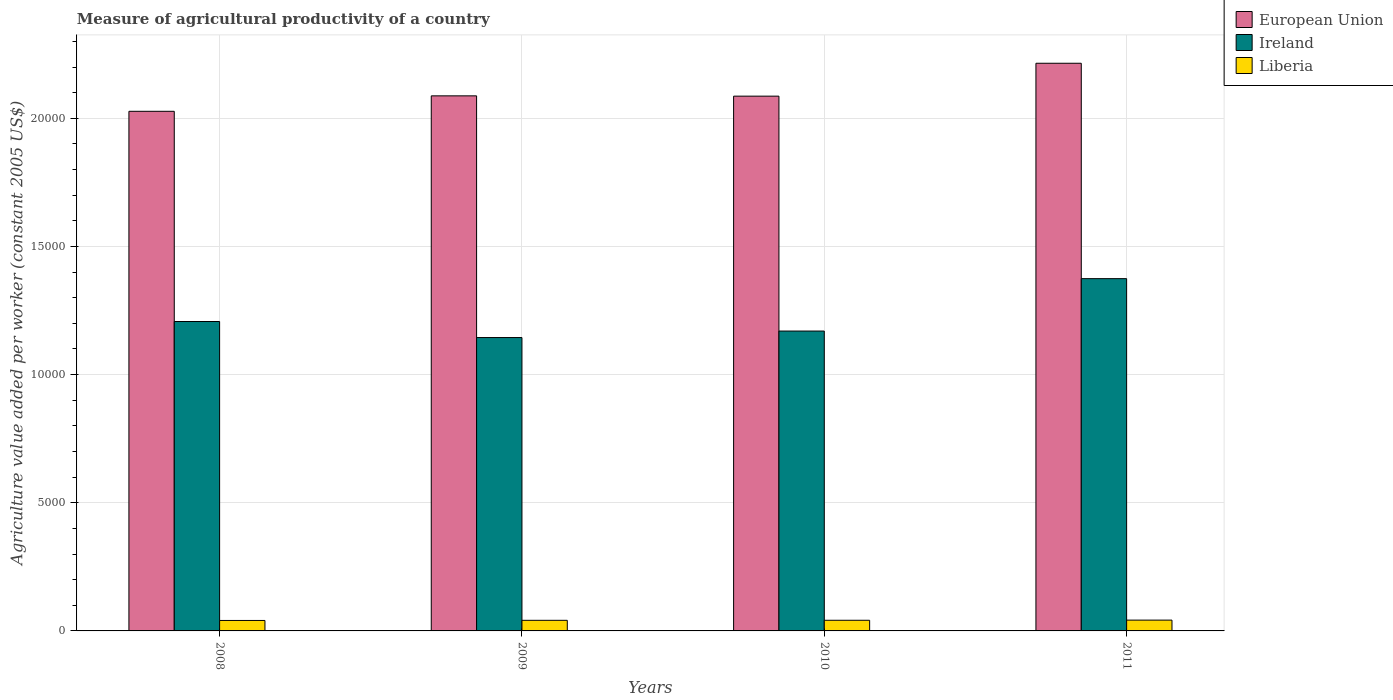Are the number of bars per tick equal to the number of legend labels?
Keep it short and to the point. Yes. Are the number of bars on each tick of the X-axis equal?
Your answer should be compact. Yes. How many bars are there on the 2nd tick from the right?
Make the answer very short. 3. What is the measure of agricultural productivity in European Union in 2009?
Ensure brevity in your answer.  2.09e+04. Across all years, what is the maximum measure of agricultural productivity in Ireland?
Provide a short and direct response. 1.37e+04. Across all years, what is the minimum measure of agricultural productivity in Ireland?
Your answer should be compact. 1.14e+04. What is the total measure of agricultural productivity in European Union in the graph?
Your answer should be compact. 8.42e+04. What is the difference between the measure of agricultural productivity in European Union in 2009 and that in 2010?
Make the answer very short. 11.47. What is the difference between the measure of agricultural productivity in European Union in 2011 and the measure of agricultural productivity in Ireland in 2010?
Your answer should be compact. 1.04e+04. What is the average measure of agricultural productivity in Liberia per year?
Ensure brevity in your answer.  414.7. In the year 2008, what is the difference between the measure of agricultural productivity in European Union and measure of agricultural productivity in Ireland?
Your answer should be very brief. 8201.47. What is the ratio of the measure of agricultural productivity in European Union in 2008 to that in 2009?
Provide a succinct answer. 0.97. Is the measure of agricultural productivity in Ireland in 2009 less than that in 2010?
Your answer should be very brief. Yes. Is the difference between the measure of agricultural productivity in European Union in 2008 and 2010 greater than the difference between the measure of agricultural productivity in Ireland in 2008 and 2010?
Provide a succinct answer. No. What is the difference between the highest and the second highest measure of agricultural productivity in European Union?
Your answer should be very brief. 1271.79. What is the difference between the highest and the lowest measure of agricultural productivity in Liberia?
Make the answer very short. 13.71. Is the sum of the measure of agricultural productivity in Liberia in 2008 and 2009 greater than the maximum measure of agricultural productivity in Ireland across all years?
Your response must be concise. No. What does the 1st bar from the right in 2008 represents?
Ensure brevity in your answer.  Liberia. Is it the case that in every year, the sum of the measure of agricultural productivity in Ireland and measure of agricultural productivity in European Union is greater than the measure of agricultural productivity in Liberia?
Your answer should be compact. Yes. How many bars are there?
Your answer should be very brief. 12. Are all the bars in the graph horizontal?
Provide a succinct answer. No. How many years are there in the graph?
Your answer should be compact. 4. What is the difference between two consecutive major ticks on the Y-axis?
Your answer should be very brief. 5000. Where does the legend appear in the graph?
Your answer should be compact. Top right. How many legend labels are there?
Ensure brevity in your answer.  3. How are the legend labels stacked?
Your response must be concise. Vertical. What is the title of the graph?
Offer a terse response. Measure of agricultural productivity of a country. Does "Senegal" appear as one of the legend labels in the graph?
Provide a short and direct response. No. What is the label or title of the X-axis?
Offer a terse response. Years. What is the label or title of the Y-axis?
Offer a very short reply. Agriculture value added per worker (constant 2005 US$). What is the Agriculture value added per worker (constant 2005 US$) in European Union in 2008?
Offer a terse response. 2.03e+04. What is the Agriculture value added per worker (constant 2005 US$) in Ireland in 2008?
Your answer should be compact. 1.21e+04. What is the Agriculture value added per worker (constant 2005 US$) in Liberia in 2008?
Offer a very short reply. 407.86. What is the Agriculture value added per worker (constant 2005 US$) in European Union in 2009?
Your response must be concise. 2.09e+04. What is the Agriculture value added per worker (constant 2005 US$) of Ireland in 2009?
Your response must be concise. 1.14e+04. What is the Agriculture value added per worker (constant 2005 US$) in Liberia in 2009?
Ensure brevity in your answer.  413.81. What is the Agriculture value added per worker (constant 2005 US$) in European Union in 2010?
Keep it short and to the point. 2.09e+04. What is the Agriculture value added per worker (constant 2005 US$) of Ireland in 2010?
Offer a very short reply. 1.17e+04. What is the Agriculture value added per worker (constant 2005 US$) of Liberia in 2010?
Make the answer very short. 415.57. What is the Agriculture value added per worker (constant 2005 US$) in European Union in 2011?
Keep it short and to the point. 2.21e+04. What is the Agriculture value added per worker (constant 2005 US$) of Ireland in 2011?
Keep it short and to the point. 1.37e+04. What is the Agriculture value added per worker (constant 2005 US$) of Liberia in 2011?
Provide a short and direct response. 421.57. Across all years, what is the maximum Agriculture value added per worker (constant 2005 US$) in European Union?
Ensure brevity in your answer.  2.21e+04. Across all years, what is the maximum Agriculture value added per worker (constant 2005 US$) of Ireland?
Keep it short and to the point. 1.37e+04. Across all years, what is the maximum Agriculture value added per worker (constant 2005 US$) of Liberia?
Provide a short and direct response. 421.57. Across all years, what is the minimum Agriculture value added per worker (constant 2005 US$) in European Union?
Keep it short and to the point. 2.03e+04. Across all years, what is the minimum Agriculture value added per worker (constant 2005 US$) in Ireland?
Your answer should be very brief. 1.14e+04. Across all years, what is the minimum Agriculture value added per worker (constant 2005 US$) of Liberia?
Offer a terse response. 407.86. What is the total Agriculture value added per worker (constant 2005 US$) of European Union in the graph?
Provide a succinct answer. 8.42e+04. What is the total Agriculture value added per worker (constant 2005 US$) in Ireland in the graph?
Give a very brief answer. 4.90e+04. What is the total Agriculture value added per worker (constant 2005 US$) in Liberia in the graph?
Provide a succinct answer. 1658.81. What is the difference between the Agriculture value added per worker (constant 2005 US$) in European Union in 2008 and that in 2009?
Ensure brevity in your answer.  -602.44. What is the difference between the Agriculture value added per worker (constant 2005 US$) of Ireland in 2008 and that in 2009?
Give a very brief answer. 625.84. What is the difference between the Agriculture value added per worker (constant 2005 US$) in Liberia in 2008 and that in 2009?
Give a very brief answer. -5.96. What is the difference between the Agriculture value added per worker (constant 2005 US$) in European Union in 2008 and that in 2010?
Offer a terse response. -590.97. What is the difference between the Agriculture value added per worker (constant 2005 US$) of Ireland in 2008 and that in 2010?
Offer a very short reply. 372.45. What is the difference between the Agriculture value added per worker (constant 2005 US$) of Liberia in 2008 and that in 2010?
Make the answer very short. -7.72. What is the difference between the Agriculture value added per worker (constant 2005 US$) in European Union in 2008 and that in 2011?
Provide a short and direct response. -1874.23. What is the difference between the Agriculture value added per worker (constant 2005 US$) in Ireland in 2008 and that in 2011?
Ensure brevity in your answer.  -1672.35. What is the difference between the Agriculture value added per worker (constant 2005 US$) in Liberia in 2008 and that in 2011?
Offer a very short reply. -13.71. What is the difference between the Agriculture value added per worker (constant 2005 US$) of European Union in 2009 and that in 2010?
Offer a very short reply. 11.47. What is the difference between the Agriculture value added per worker (constant 2005 US$) in Ireland in 2009 and that in 2010?
Your answer should be very brief. -253.39. What is the difference between the Agriculture value added per worker (constant 2005 US$) in Liberia in 2009 and that in 2010?
Offer a terse response. -1.76. What is the difference between the Agriculture value added per worker (constant 2005 US$) in European Union in 2009 and that in 2011?
Make the answer very short. -1271.79. What is the difference between the Agriculture value added per worker (constant 2005 US$) of Ireland in 2009 and that in 2011?
Make the answer very short. -2298.19. What is the difference between the Agriculture value added per worker (constant 2005 US$) of Liberia in 2009 and that in 2011?
Offer a very short reply. -7.76. What is the difference between the Agriculture value added per worker (constant 2005 US$) in European Union in 2010 and that in 2011?
Make the answer very short. -1283.26. What is the difference between the Agriculture value added per worker (constant 2005 US$) of Ireland in 2010 and that in 2011?
Your response must be concise. -2044.81. What is the difference between the Agriculture value added per worker (constant 2005 US$) in Liberia in 2010 and that in 2011?
Make the answer very short. -6. What is the difference between the Agriculture value added per worker (constant 2005 US$) in European Union in 2008 and the Agriculture value added per worker (constant 2005 US$) in Ireland in 2009?
Offer a very short reply. 8827.31. What is the difference between the Agriculture value added per worker (constant 2005 US$) of European Union in 2008 and the Agriculture value added per worker (constant 2005 US$) of Liberia in 2009?
Make the answer very short. 1.99e+04. What is the difference between the Agriculture value added per worker (constant 2005 US$) in Ireland in 2008 and the Agriculture value added per worker (constant 2005 US$) in Liberia in 2009?
Offer a very short reply. 1.17e+04. What is the difference between the Agriculture value added per worker (constant 2005 US$) of European Union in 2008 and the Agriculture value added per worker (constant 2005 US$) of Ireland in 2010?
Your answer should be compact. 8573.92. What is the difference between the Agriculture value added per worker (constant 2005 US$) of European Union in 2008 and the Agriculture value added per worker (constant 2005 US$) of Liberia in 2010?
Provide a succinct answer. 1.99e+04. What is the difference between the Agriculture value added per worker (constant 2005 US$) in Ireland in 2008 and the Agriculture value added per worker (constant 2005 US$) in Liberia in 2010?
Provide a short and direct response. 1.17e+04. What is the difference between the Agriculture value added per worker (constant 2005 US$) of European Union in 2008 and the Agriculture value added per worker (constant 2005 US$) of Ireland in 2011?
Offer a very short reply. 6529.12. What is the difference between the Agriculture value added per worker (constant 2005 US$) in European Union in 2008 and the Agriculture value added per worker (constant 2005 US$) in Liberia in 2011?
Your response must be concise. 1.99e+04. What is the difference between the Agriculture value added per worker (constant 2005 US$) of Ireland in 2008 and the Agriculture value added per worker (constant 2005 US$) of Liberia in 2011?
Your response must be concise. 1.17e+04. What is the difference between the Agriculture value added per worker (constant 2005 US$) of European Union in 2009 and the Agriculture value added per worker (constant 2005 US$) of Ireland in 2010?
Your answer should be very brief. 9176.36. What is the difference between the Agriculture value added per worker (constant 2005 US$) of European Union in 2009 and the Agriculture value added per worker (constant 2005 US$) of Liberia in 2010?
Make the answer very short. 2.05e+04. What is the difference between the Agriculture value added per worker (constant 2005 US$) in Ireland in 2009 and the Agriculture value added per worker (constant 2005 US$) in Liberia in 2010?
Keep it short and to the point. 1.10e+04. What is the difference between the Agriculture value added per worker (constant 2005 US$) in European Union in 2009 and the Agriculture value added per worker (constant 2005 US$) in Ireland in 2011?
Your answer should be compact. 7131.55. What is the difference between the Agriculture value added per worker (constant 2005 US$) of European Union in 2009 and the Agriculture value added per worker (constant 2005 US$) of Liberia in 2011?
Offer a terse response. 2.05e+04. What is the difference between the Agriculture value added per worker (constant 2005 US$) in Ireland in 2009 and the Agriculture value added per worker (constant 2005 US$) in Liberia in 2011?
Give a very brief answer. 1.10e+04. What is the difference between the Agriculture value added per worker (constant 2005 US$) of European Union in 2010 and the Agriculture value added per worker (constant 2005 US$) of Ireland in 2011?
Keep it short and to the point. 7120.08. What is the difference between the Agriculture value added per worker (constant 2005 US$) in European Union in 2010 and the Agriculture value added per worker (constant 2005 US$) in Liberia in 2011?
Provide a succinct answer. 2.04e+04. What is the difference between the Agriculture value added per worker (constant 2005 US$) in Ireland in 2010 and the Agriculture value added per worker (constant 2005 US$) in Liberia in 2011?
Keep it short and to the point. 1.13e+04. What is the average Agriculture value added per worker (constant 2005 US$) in European Union per year?
Offer a very short reply. 2.10e+04. What is the average Agriculture value added per worker (constant 2005 US$) of Ireland per year?
Keep it short and to the point. 1.22e+04. What is the average Agriculture value added per worker (constant 2005 US$) in Liberia per year?
Provide a short and direct response. 414.7. In the year 2008, what is the difference between the Agriculture value added per worker (constant 2005 US$) of European Union and Agriculture value added per worker (constant 2005 US$) of Ireland?
Your answer should be compact. 8201.47. In the year 2008, what is the difference between the Agriculture value added per worker (constant 2005 US$) in European Union and Agriculture value added per worker (constant 2005 US$) in Liberia?
Ensure brevity in your answer.  1.99e+04. In the year 2008, what is the difference between the Agriculture value added per worker (constant 2005 US$) in Ireland and Agriculture value added per worker (constant 2005 US$) in Liberia?
Give a very brief answer. 1.17e+04. In the year 2009, what is the difference between the Agriculture value added per worker (constant 2005 US$) in European Union and Agriculture value added per worker (constant 2005 US$) in Ireland?
Provide a short and direct response. 9429.74. In the year 2009, what is the difference between the Agriculture value added per worker (constant 2005 US$) in European Union and Agriculture value added per worker (constant 2005 US$) in Liberia?
Provide a short and direct response. 2.05e+04. In the year 2009, what is the difference between the Agriculture value added per worker (constant 2005 US$) in Ireland and Agriculture value added per worker (constant 2005 US$) in Liberia?
Keep it short and to the point. 1.10e+04. In the year 2010, what is the difference between the Agriculture value added per worker (constant 2005 US$) of European Union and Agriculture value added per worker (constant 2005 US$) of Ireland?
Your response must be concise. 9164.89. In the year 2010, what is the difference between the Agriculture value added per worker (constant 2005 US$) in European Union and Agriculture value added per worker (constant 2005 US$) in Liberia?
Your answer should be very brief. 2.04e+04. In the year 2010, what is the difference between the Agriculture value added per worker (constant 2005 US$) in Ireland and Agriculture value added per worker (constant 2005 US$) in Liberia?
Your answer should be compact. 1.13e+04. In the year 2011, what is the difference between the Agriculture value added per worker (constant 2005 US$) of European Union and Agriculture value added per worker (constant 2005 US$) of Ireland?
Provide a succinct answer. 8403.35. In the year 2011, what is the difference between the Agriculture value added per worker (constant 2005 US$) of European Union and Agriculture value added per worker (constant 2005 US$) of Liberia?
Make the answer very short. 2.17e+04. In the year 2011, what is the difference between the Agriculture value added per worker (constant 2005 US$) in Ireland and Agriculture value added per worker (constant 2005 US$) in Liberia?
Give a very brief answer. 1.33e+04. What is the ratio of the Agriculture value added per worker (constant 2005 US$) in European Union in 2008 to that in 2009?
Provide a succinct answer. 0.97. What is the ratio of the Agriculture value added per worker (constant 2005 US$) of Ireland in 2008 to that in 2009?
Your response must be concise. 1.05. What is the ratio of the Agriculture value added per worker (constant 2005 US$) of Liberia in 2008 to that in 2009?
Keep it short and to the point. 0.99. What is the ratio of the Agriculture value added per worker (constant 2005 US$) in European Union in 2008 to that in 2010?
Give a very brief answer. 0.97. What is the ratio of the Agriculture value added per worker (constant 2005 US$) of Ireland in 2008 to that in 2010?
Offer a terse response. 1.03. What is the ratio of the Agriculture value added per worker (constant 2005 US$) of Liberia in 2008 to that in 2010?
Ensure brevity in your answer.  0.98. What is the ratio of the Agriculture value added per worker (constant 2005 US$) in European Union in 2008 to that in 2011?
Your response must be concise. 0.92. What is the ratio of the Agriculture value added per worker (constant 2005 US$) of Ireland in 2008 to that in 2011?
Offer a very short reply. 0.88. What is the ratio of the Agriculture value added per worker (constant 2005 US$) in Liberia in 2008 to that in 2011?
Offer a terse response. 0.97. What is the ratio of the Agriculture value added per worker (constant 2005 US$) in Ireland in 2009 to that in 2010?
Provide a succinct answer. 0.98. What is the ratio of the Agriculture value added per worker (constant 2005 US$) of Liberia in 2009 to that in 2010?
Your answer should be compact. 1. What is the ratio of the Agriculture value added per worker (constant 2005 US$) in European Union in 2009 to that in 2011?
Provide a short and direct response. 0.94. What is the ratio of the Agriculture value added per worker (constant 2005 US$) in Ireland in 2009 to that in 2011?
Keep it short and to the point. 0.83. What is the ratio of the Agriculture value added per worker (constant 2005 US$) of Liberia in 2009 to that in 2011?
Your answer should be compact. 0.98. What is the ratio of the Agriculture value added per worker (constant 2005 US$) in European Union in 2010 to that in 2011?
Provide a short and direct response. 0.94. What is the ratio of the Agriculture value added per worker (constant 2005 US$) of Ireland in 2010 to that in 2011?
Your answer should be very brief. 0.85. What is the ratio of the Agriculture value added per worker (constant 2005 US$) in Liberia in 2010 to that in 2011?
Your response must be concise. 0.99. What is the difference between the highest and the second highest Agriculture value added per worker (constant 2005 US$) of European Union?
Your answer should be compact. 1271.79. What is the difference between the highest and the second highest Agriculture value added per worker (constant 2005 US$) of Ireland?
Ensure brevity in your answer.  1672.35. What is the difference between the highest and the second highest Agriculture value added per worker (constant 2005 US$) of Liberia?
Your answer should be very brief. 6. What is the difference between the highest and the lowest Agriculture value added per worker (constant 2005 US$) in European Union?
Your answer should be very brief. 1874.23. What is the difference between the highest and the lowest Agriculture value added per worker (constant 2005 US$) in Ireland?
Keep it short and to the point. 2298.19. What is the difference between the highest and the lowest Agriculture value added per worker (constant 2005 US$) of Liberia?
Give a very brief answer. 13.71. 